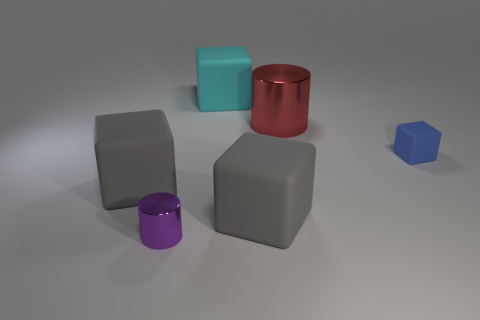Add 2 matte cubes. How many objects exist? 8 Subtract all cylinders. How many objects are left? 4 Subtract 0 green cubes. How many objects are left? 6 Subtract all large gray blocks. Subtract all purple things. How many objects are left? 3 Add 5 purple cylinders. How many purple cylinders are left? 6 Add 2 tiny green rubber blocks. How many tiny green rubber blocks exist? 2 